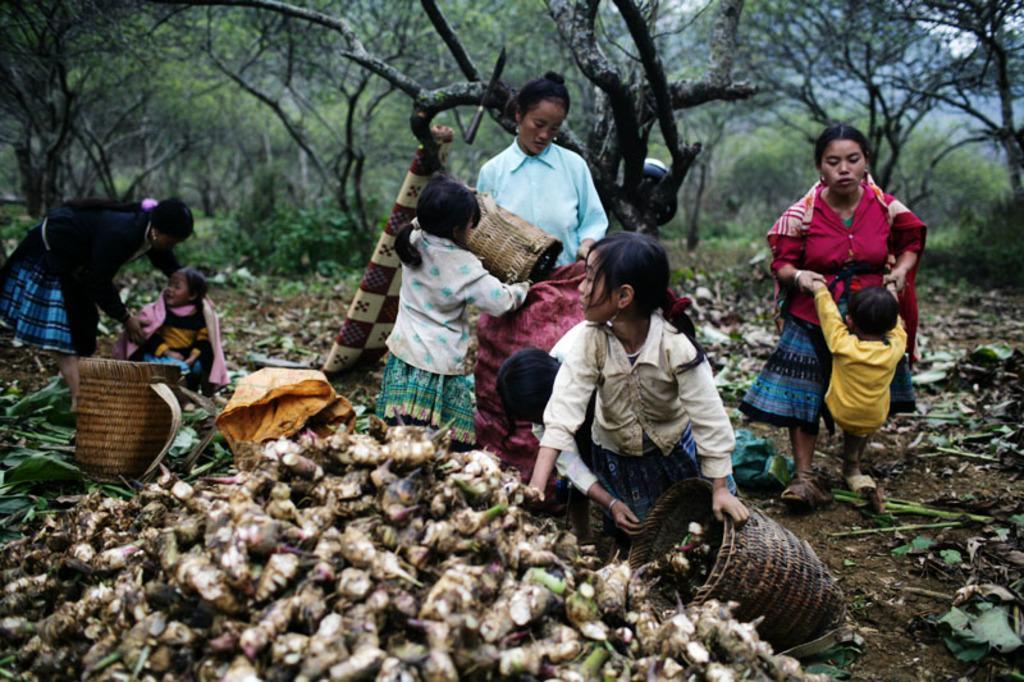How would you summarize this image in a sentence or two? In this picture I can see group of people, there are baskets, those are looking like sweet potatoes, and in the background there are trees. 